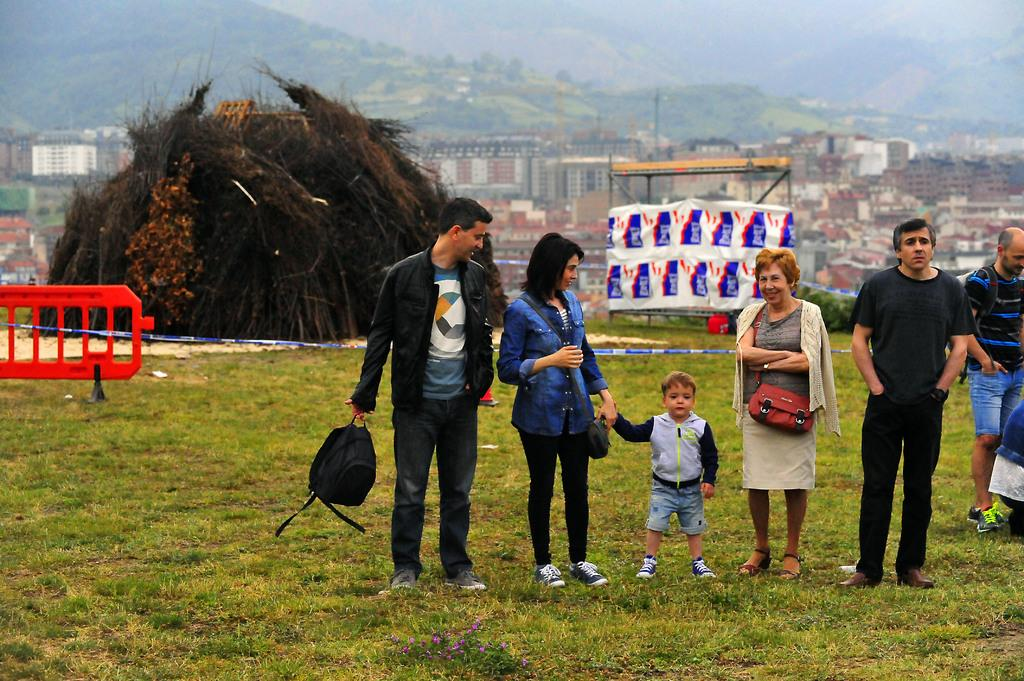What type of vegetation is present in the image? There is grass in the image. Who or what can be seen in the image? There are people in the image. What geographical feature is visible in the image? There is a hill in the image. What type of man-made structures are present in the image? There are buildings in the image. How many eyes can be seen on the hill in the image? There are no eyes present on the hill in the image; it is a geographical feature. 